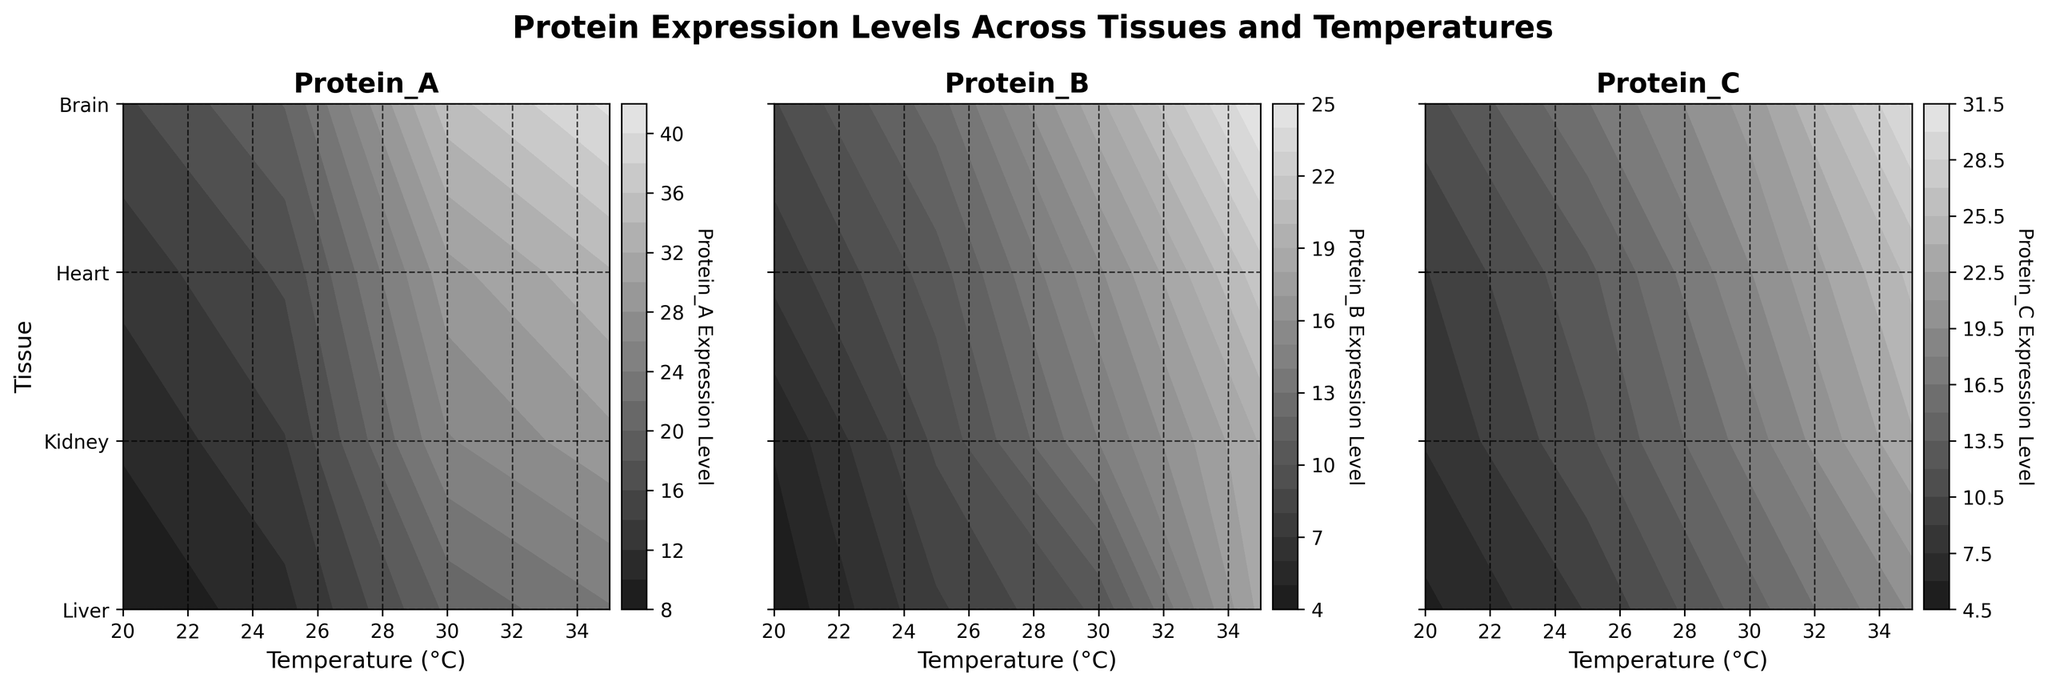What are the x-axis and y-axis labels on the plots? The x-axis label is "Temperature (°C)" and the y-axis label is "Tissue".
Answer: Temperature (°C) and Tissue Which protein shows the highest expression level at 35°C in the Liver tissue? To find this, locate the highest level for the Liver tissue at 35°C on the plots for Proteins A, B, and C. Protein A shows the highest expression level of 40.5.
Answer: Protein A How does the expression level of Protein B in the Kidney change from 20°C to 35°C? Locate the expression levels of Protein B in the Kidney on the plot at 20°C, 25°C, 30°C, and 35°C. The values are 7.3, 10.5, 15.8, and 21.6, indicating a steady increase.
Answer: Increases Which tissue has the lowest expression levels of Protein C across all temperatures? By comparing the contour plots for Protein C across all tissues and temperatures, the Heart shows the lowest expression levels overall.
Answer: Heart What is the overall trend in protein expression levels across different tissues and temperatures? By observing the contour plots, protein expression levels generally increase with the rise in temperature across all tissue types. Each tissue shows this upward trend, confirming it.
Answer: Increase with temperature Comparing Protein A at 25°C, which tissue has the highest expression level? Check the expression levels of Protein A at 25°C for all tissues. Liver has the highest expression level with a value of 20.1.
Answer: Liver What's the average expression level of Protein C in the Brain tissue across all temperatures? The expression levels of Protein C in the Brain tissue at 20°C, 25°C, 30°C, and 35°C are 5.6, 9.1, 14.3, and 19.7. Computing the average: (5.6 + 9.1 + 14.3 + 19.7) / 4 = 12.175.
Answer: 12.175 Is there any tissue where Protein B has a higher expression level than Protein A at 30°C? Compare the values of Protein B and Protein A at 30°C for all tissues: Liver, Kidney, Heart, Brain. Protein A is always higher than Protein B at this temperature.
Answer: No Which protein shows the most significant increase in expression level in the Heart tissue from 20°C to 35°C? For the Heart tissue, determine the increase for each protein from 20°C to 35°C: Protein_A: 29.4 - 10.3 = 19.1, Protein_B: 19.1 - 5.1 = 14, Protein_C: 23.8 - 7.6 = 16.2. Protein A shows the most significant increase.
Answer: Protein A In which temperature range does the Liver tissue have the most dramatic increase in Protein C expression? Examine the Liver tissue's Protein C expression levels: 20°C (11.3), 25°C (16.4), 30°C (21.6), 35°C (30.2). The largest increase happens from 30°C to 35°C (30.2 - 21.6 = 8.6).
Answer: 30°C to 35°C 